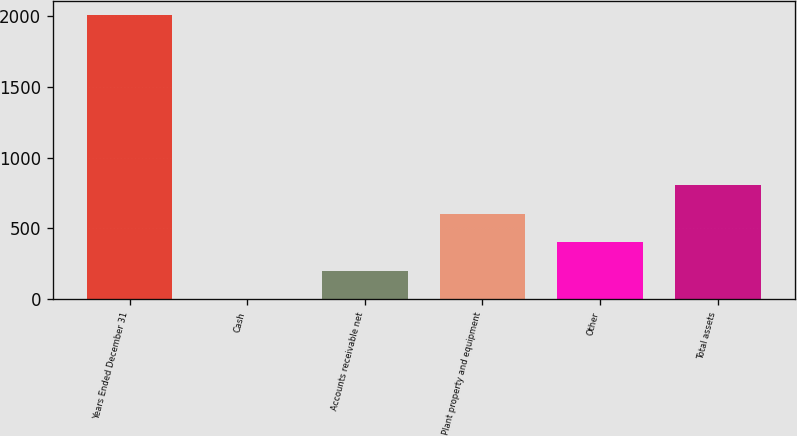Convert chart to OTSL. <chart><loc_0><loc_0><loc_500><loc_500><bar_chart><fcel>Years Ended December 31<fcel>Cash<fcel>Accounts receivable net<fcel>Plant property and equipment<fcel>Other<fcel>Total assets<nl><fcel>2009<fcel>1<fcel>201.8<fcel>603.4<fcel>402.6<fcel>804.2<nl></chart> 